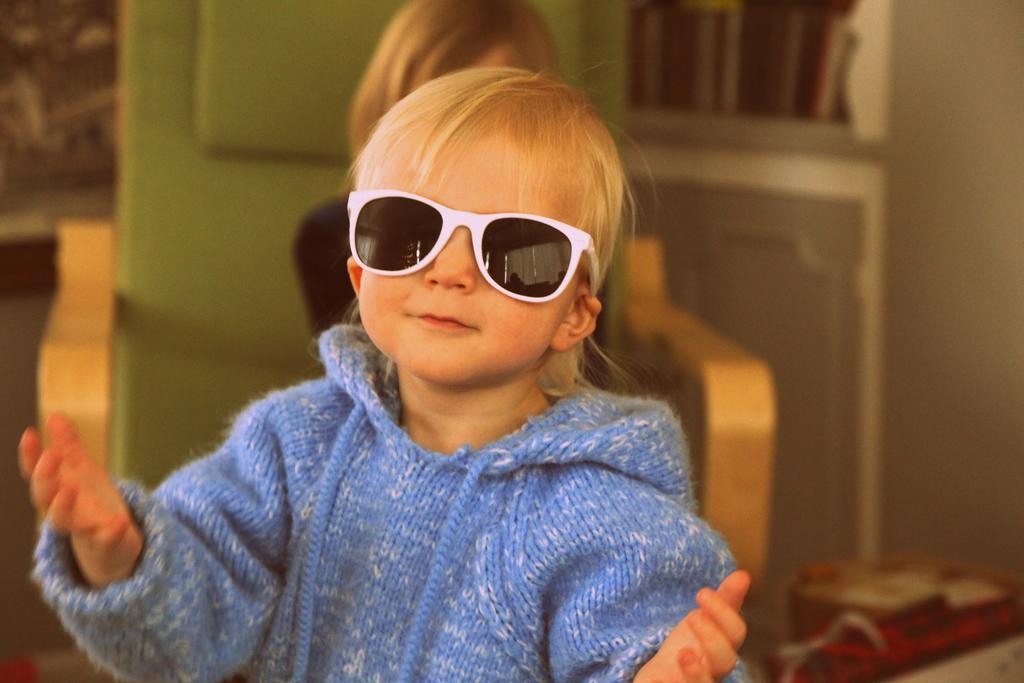Can you describe this image briefly? In the picture is a child wearing glasses, behind her there is a chair, there is a person sitting on the chair. 